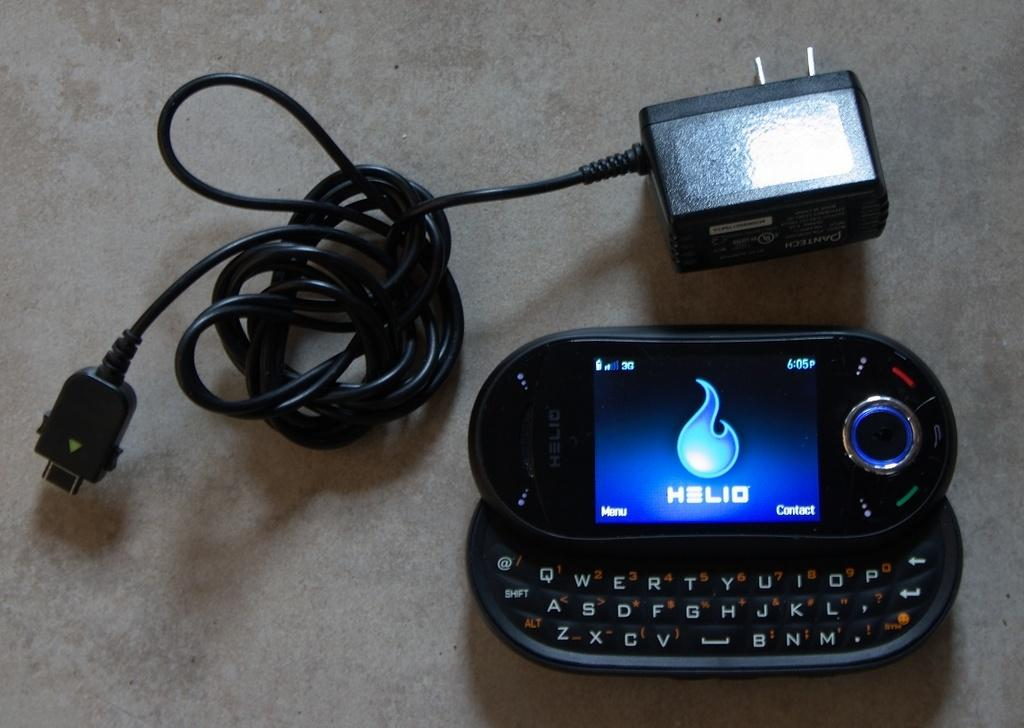Provide a one-sentence caption for the provided image. a cellphone open to a screen reading HELIO next to a charger. 